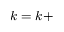<formula> <loc_0><loc_0><loc_500><loc_500>k = k +</formula> 